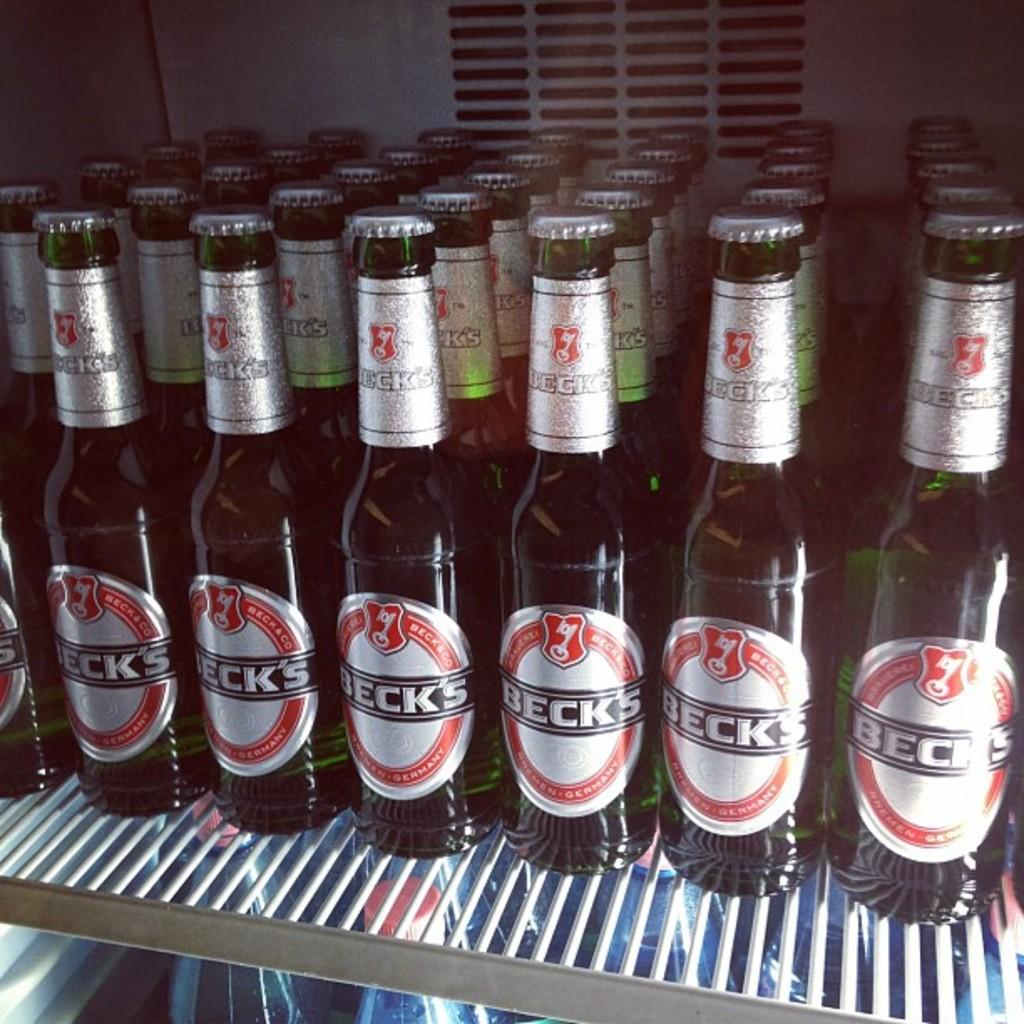What type of beer is it?
Make the answer very short. Beck's. What brand of beer is this?
Your response must be concise. Beck's. 